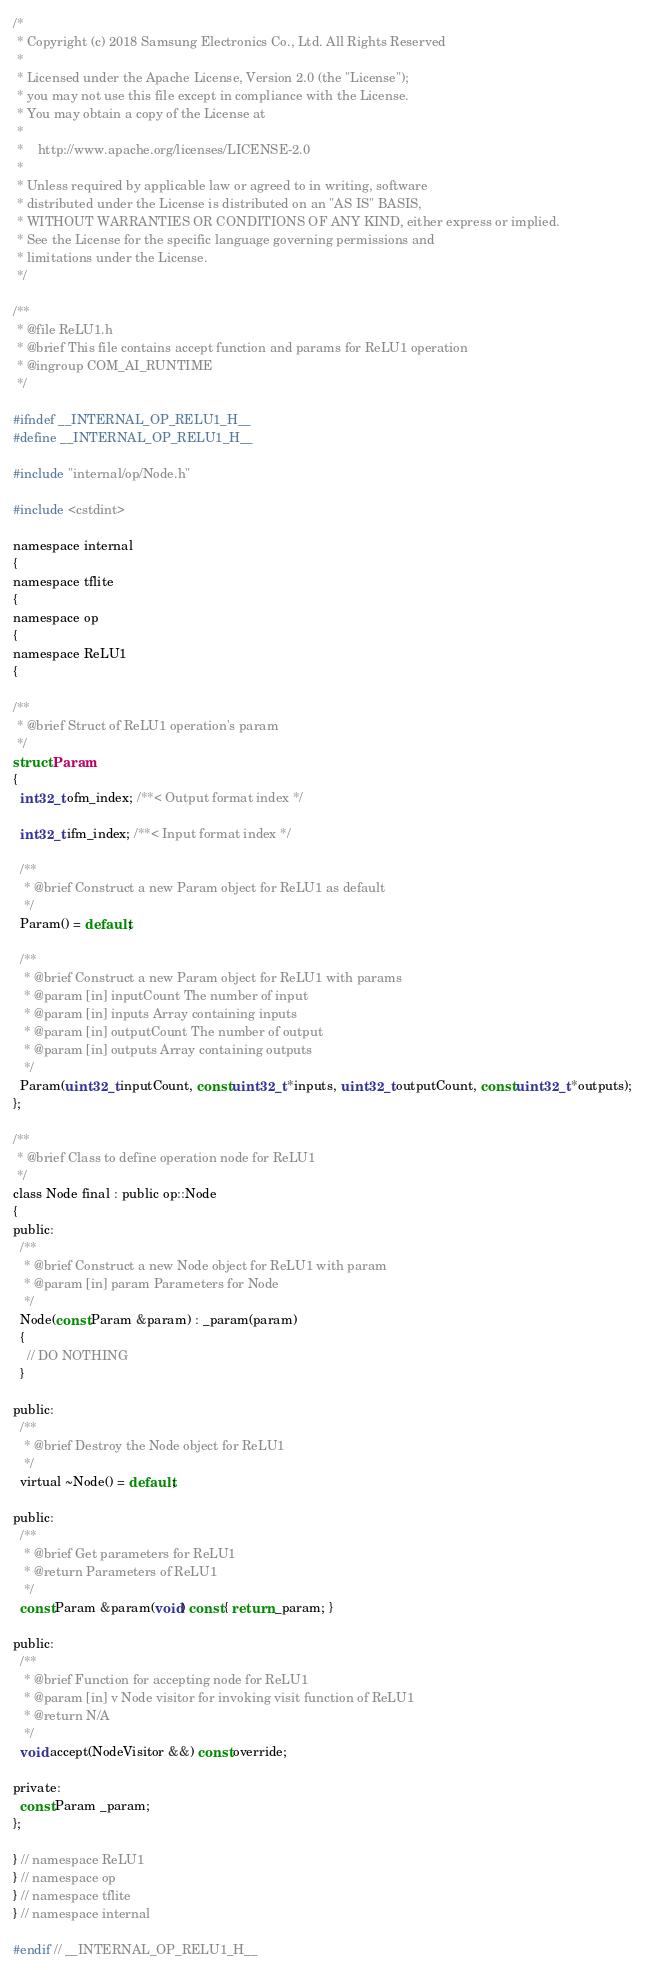<code> <loc_0><loc_0><loc_500><loc_500><_C_>/*
 * Copyright (c) 2018 Samsung Electronics Co., Ltd. All Rights Reserved
 *
 * Licensed under the Apache License, Version 2.0 (the "License");
 * you may not use this file except in compliance with the License.
 * You may obtain a copy of the License at
 *
 *    http://www.apache.org/licenses/LICENSE-2.0
 *
 * Unless required by applicable law or agreed to in writing, software
 * distributed under the License is distributed on an "AS IS" BASIS,
 * WITHOUT WARRANTIES OR CONDITIONS OF ANY KIND, either express or implied.
 * See the License for the specific language governing permissions and
 * limitations under the License.
 */

/**
 * @file ReLU1.h
 * @brief This file contains accept function and params for ReLU1 operation
 * @ingroup COM_AI_RUNTIME
 */

#ifndef __INTERNAL_OP_RELU1_H__
#define __INTERNAL_OP_RELU1_H__

#include "internal/op/Node.h"

#include <cstdint>

namespace internal
{
namespace tflite
{
namespace op
{
namespace ReLU1
{

/**
 * @brief Struct of ReLU1 operation's param
 */
struct Param
{
  int32_t ofm_index; /**< Output format index */

  int32_t ifm_index; /**< Input format index */

  /**
   * @brief Construct a new Param object for ReLU1 as default
   */
  Param() = default;

  /**
   * @brief Construct a new Param object for ReLU1 with params
   * @param [in] inputCount The number of input
   * @param [in] inputs Array containing inputs
   * @param [in] outputCount The number of output
   * @param [in] outputs Array containing outputs
   */
  Param(uint32_t inputCount, const uint32_t *inputs, uint32_t outputCount, const uint32_t *outputs);
};

/**
 * @brief Class to define operation node for ReLU1
 */
class Node final : public op::Node
{
public:
  /**
   * @brief Construct a new Node object for ReLU1 with param
   * @param [in] param Parameters for Node
   */
  Node(const Param &param) : _param(param)
  {
    // DO NOTHING
  }

public:
  /**
   * @brief Destroy the Node object for ReLU1
   */
  virtual ~Node() = default;

public:
  /**
   * @brief Get parameters for ReLU1
   * @return Parameters of ReLU1
   */
  const Param &param(void) const { return _param; }

public:
  /**
   * @brief Function for accepting node for ReLU1
   * @param [in] v Node visitor for invoking visit function of ReLU1
   * @return N/A
   */
  void accept(NodeVisitor &&) const override;

private:
  const Param _param;
};

} // namespace ReLU1
} // namespace op
} // namespace tflite
} // namespace internal

#endif // __INTERNAL_OP_RELU1_H__
</code> 